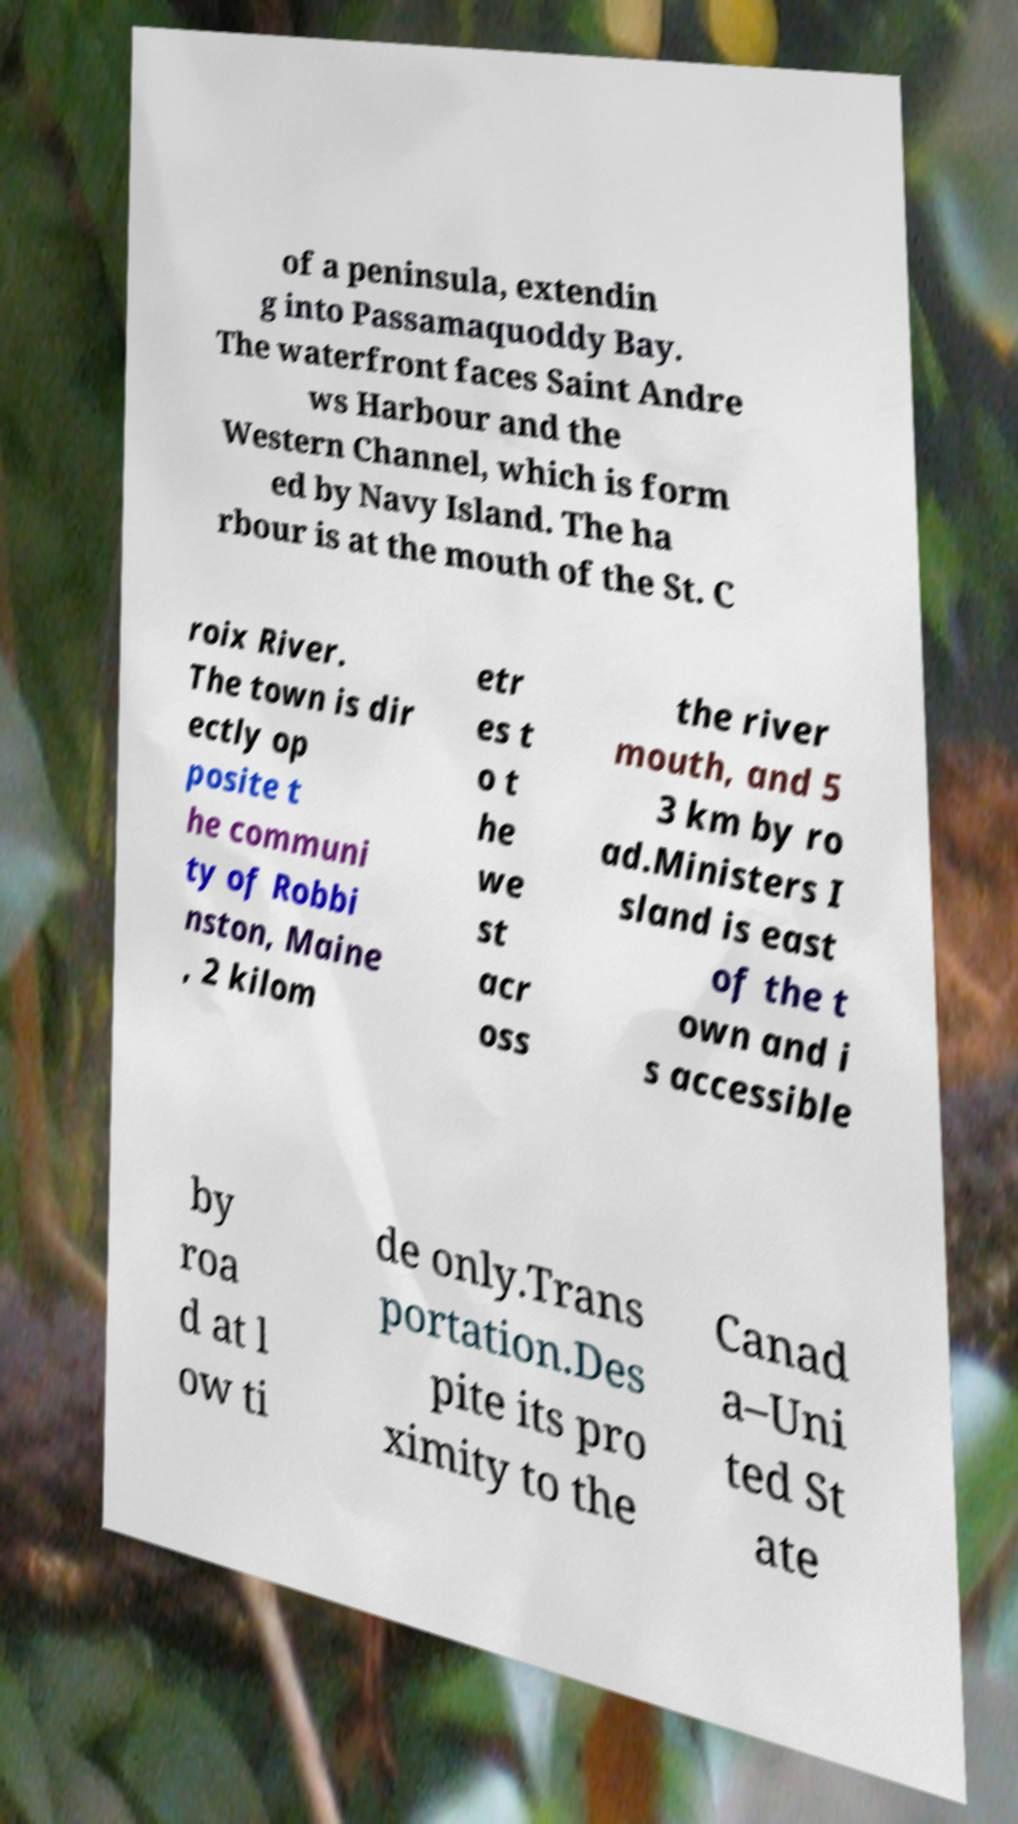Please identify and transcribe the text found in this image. of a peninsula, extendin g into Passamaquoddy Bay. The waterfront faces Saint Andre ws Harbour and the Western Channel, which is form ed by Navy Island. The ha rbour is at the mouth of the St. C roix River. The town is dir ectly op posite t he communi ty of Robbi nston, Maine , 2 kilom etr es t o t he we st acr oss the river mouth, and 5 3 km by ro ad.Ministers I sland is east of the t own and i s accessible by roa d at l ow ti de only.Trans portation.Des pite its pro ximity to the Canad a–Uni ted St ate 